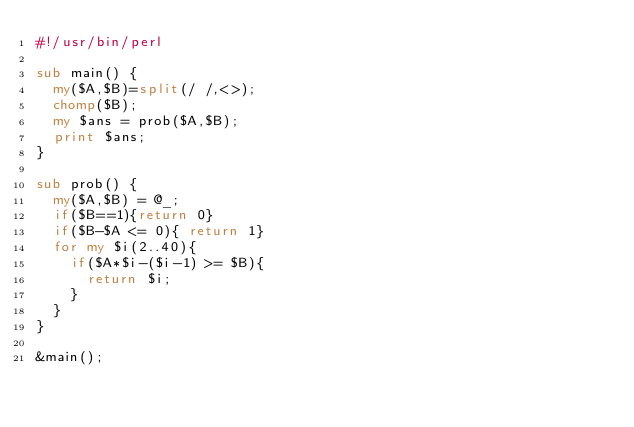Convert code to text. <code><loc_0><loc_0><loc_500><loc_500><_Perl_>#!/usr/bin/perl

sub main() {
  my($A,$B)=split(/ /,<>);
  chomp($B);
  my $ans = prob($A,$B);
  print $ans;
}

sub prob() {
  my($A,$B) = @_;
  if($B==1){return 0}
  if($B-$A <= 0){ return 1}
  for my $i(2..40){
    if($A*$i-($i-1) >= $B){
      return $i;
    }
  }
}

&main();</code> 